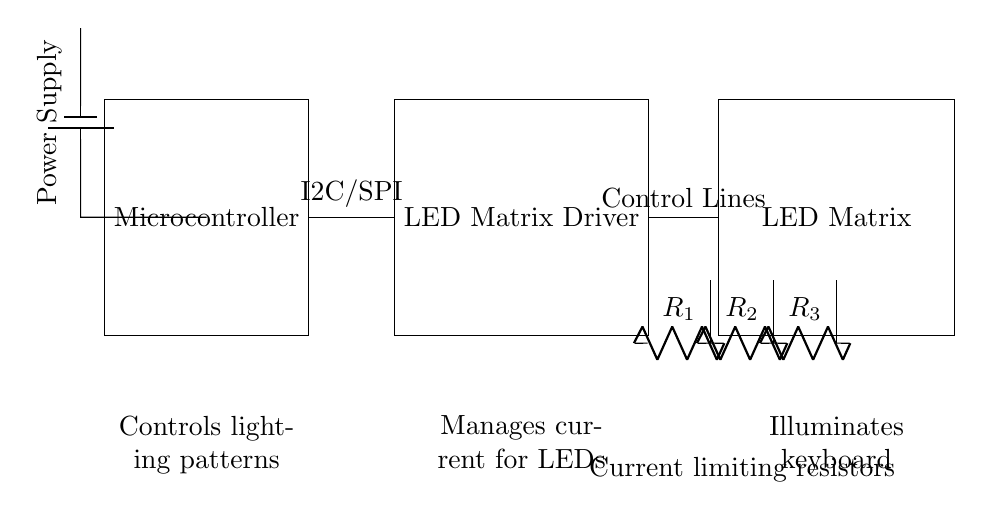What is the power supply type in the circuit? The circuit uses a battery as indicated by the battery symbol, which is commonly used as a power supply for circuits.
Answer: Battery What type of communication does the microcontroller use to connect with the LED matrix driver? The diagram shows that the microcontroller connects to the LED matrix driver using I2C or SPI, which are protocols for communication between devices.
Answer: I2C/SPI How many resistors are present in the circuit? By examining the diagram, there are three resistors labeled as R1, R2, and R3.
Answer: Three What does the LED matrix driver do in the circuit? The LED matrix driver's primary role is to manage the current supplied to the LEDs, ensuring they operate within safe limits and create desired lighting effects.
Answer: Manages current for LEDs Which component illuminates the keyboard? The LED matrix is shown as the part of the circuit designated to illuminate the keyboard itself, as it's directly responsible for lighting effects.
Answer: LED Matrix Explain the connection between the LED matrix driver and the LED matrix. The connection is labeled as "Control Lines" and indicates that the driver sends control signals to regulate the operation of the LED matrix.
Answer: Control Lines What are the components labeled near the resistors for? The components labeled as current limiting resistors are used to limit the amount of current flowing to the LEDs, preventing damage from excessive current.
Answer: Current limiting resistors 